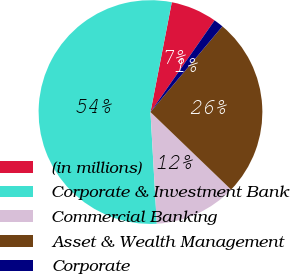Convert chart. <chart><loc_0><loc_0><loc_500><loc_500><pie_chart><fcel>(in millions)<fcel>Corporate & Investment Bank<fcel>Commercial Banking<fcel>Asset & Wealth Management<fcel>Corporate<nl><fcel>6.66%<fcel>53.95%<fcel>11.91%<fcel>26.08%<fcel>1.4%<nl></chart> 